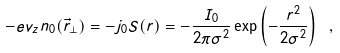<formula> <loc_0><loc_0><loc_500><loc_500>- e v _ { z } n _ { 0 } ( \vec { r } _ { \perp } ) = - j _ { 0 } S ( r ) = - \frac { I _ { 0 } } { 2 \pi \sigma ^ { 2 } } \exp \left ( - \frac { r ^ { 2 } } { 2 \sigma ^ { 2 } } \right ) \ ,</formula> 